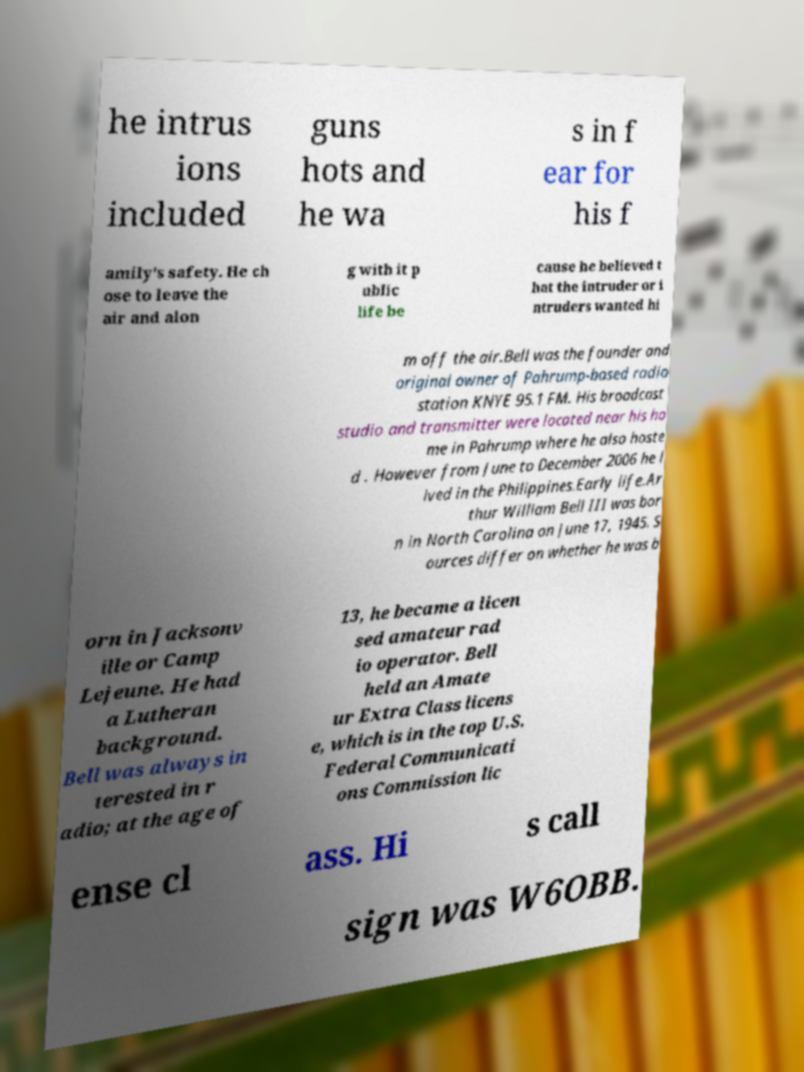There's text embedded in this image that I need extracted. Can you transcribe it verbatim? he intrus ions included guns hots and he wa s in f ear for his f amily's safety. He ch ose to leave the air and alon g with it p ublic life be cause he believed t hat the intruder or i ntruders wanted hi m off the air.Bell was the founder and original owner of Pahrump-based radio station KNYE 95.1 FM. His broadcast studio and transmitter were located near his ho me in Pahrump where he also hoste d . However from June to December 2006 he l ived in the Philippines.Early life.Ar thur William Bell III was bor n in North Carolina on June 17, 1945. S ources differ on whether he was b orn in Jacksonv ille or Camp Lejeune. He had a Lutheran background. Bell was always in terested in r adio; at the age of 13, he became a licen sed amateur rad io operator. Bell held an Amate ur Extra Class licens e, which is in the top U.S. Federal Communicati ons Commission lic ense cl ass. Hi s call sign was W6OBB. 